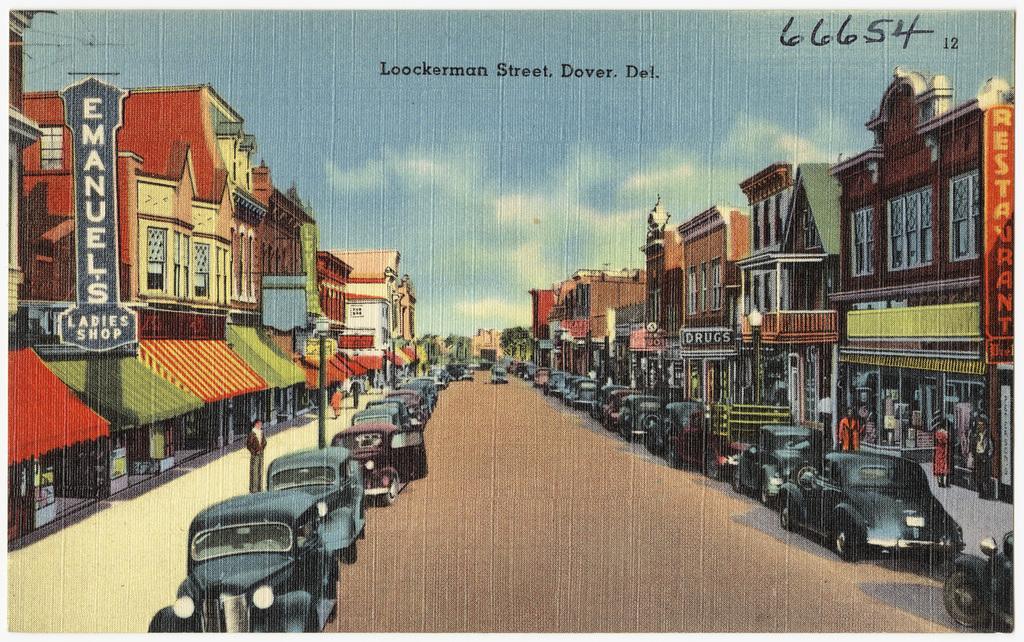Could you give a brief overview of what you see in this image? This is a painting, in this image there are cars on a road, on either side of the road there is a footpath, on that footpath people are walking and there are shops in the background there is a blue sky, at the top there is text, in the top right there is a number. 